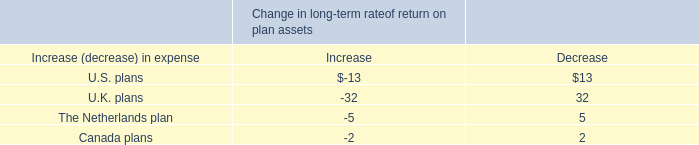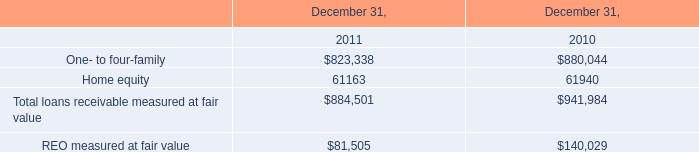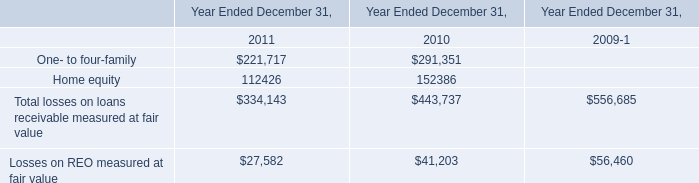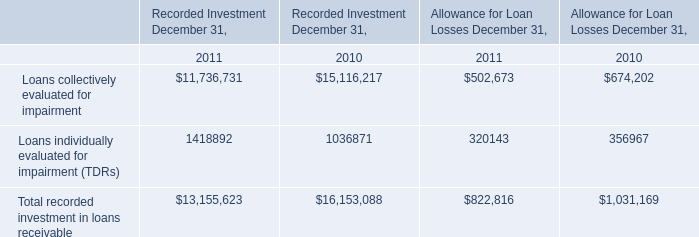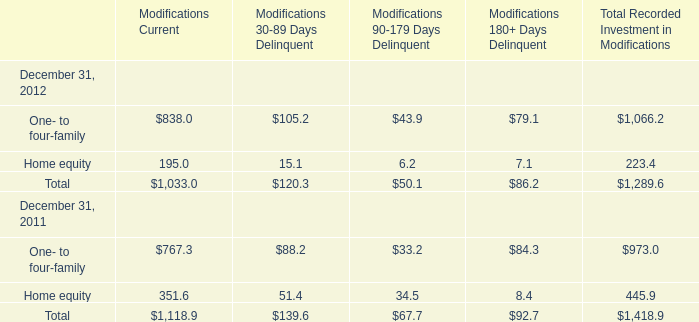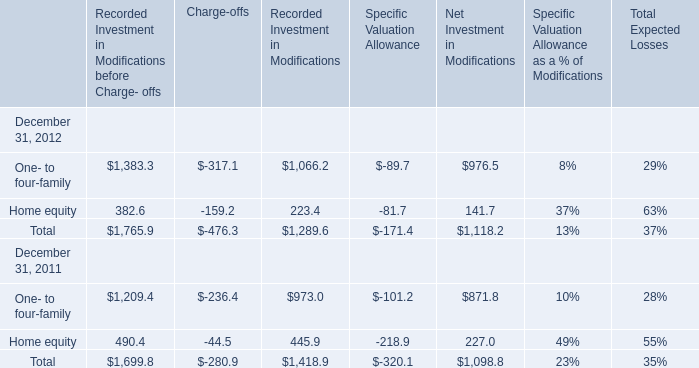What will One- to four-family's Modifications Current reach in 2013 if it continues to grow at its current rate? 
Computations: ((1 + ((838 - 767.3) / 767.3)) * 838)
Answer: 915.21439. 